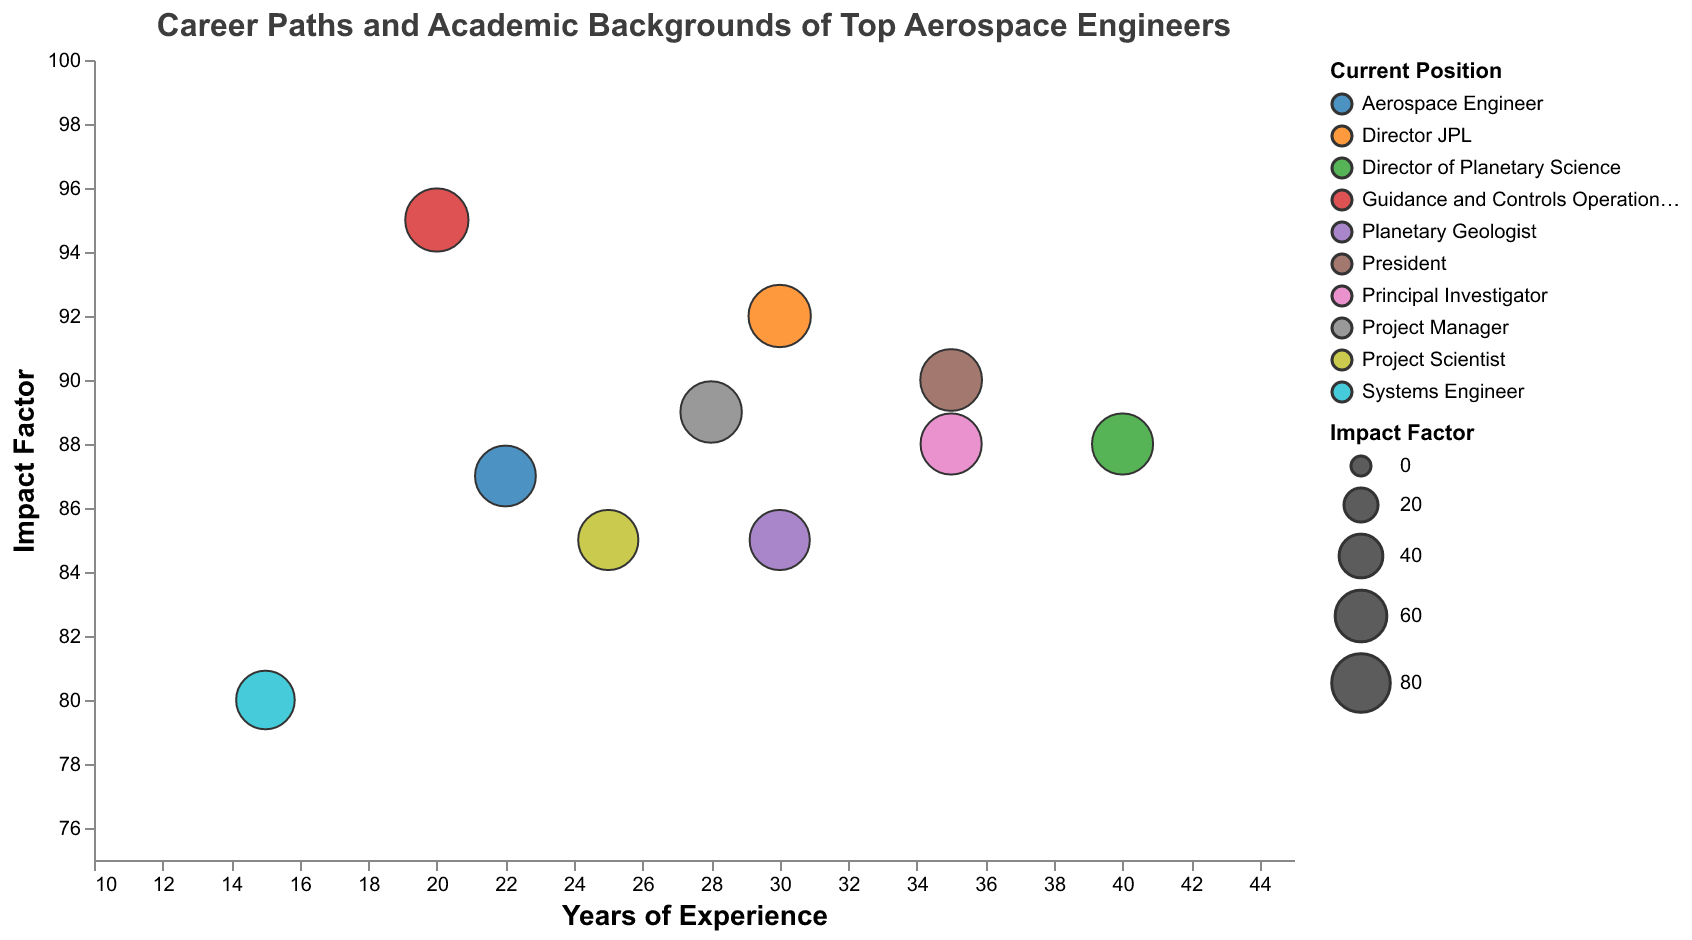How many engineers have an impact factor greater than 90? By examining the y-axis and observing the data points, we can count the number of bubbles whose 'Impact Factor' is above 90.
Answer: 3 Who among the engineers has the highest 'Impact Factor' and what is their current position? The highest 'Impact Factor' can be found by observing the data point at the highest position on the y-axis. Look at the tooltip to identify the engineer and their current position.
Answer: Dr. Swati Mohan, Guidance and Controls Operations Lead Which engineer with over 30 years of experience has the lowest 'Impact Factor'? Filter the data points for those with more than 30 years of experience by looking at the x-axis, and among these, identify the one with the lowest position on the y-axis.
Answer: Dr. Ellen Stofan What is the average 'Impact Factor' of engineers with exactly 30 years of experience? There are three engineers with 30 years of experience. Find their 'Impact Factors' and then calculate the average: (85 + 85 + 92) / 3 = 87.33
Answer: 87.33 Which position has the most number of engineers represented in the chart? Look at the color-coded groups representing different positions, and count the number of data points for each group.
Answer: PhD Which engineer has contributed to the Perseverance rover landing, and what is their 'Impact Factor'? Locate the specific contribution "Perseverance rover landing" by examining the tooltip of the data points, then note the corresponding 'Impact Factor'.
Answer: Dr. Swati Mohan, 95 Among the engineers with experience ranging from 25 to 30 years, who has the highest 'Impact Factor'? Filter out the data points that fall within 25-30 years of experience from the x-axis and identify the highest value on the y-axis within this range.
Answer: Dr. Michael Watkins Is there any visible correlation between 'Years of Experience' and 'Impact Factor'? Examine whether there is any noticeable trend or relationship between the x-axis (Years of Experience) and the y-axis (Impact Factor).
Answer: No clear correlation Which engineer worked on the Mars Science Laboratory and what is their 'Impact Factor’? Scan the tooltips to identify the engineer associated with the Mars Science Laboratory, then note their 'Impact Factor'.
Answer: Dr. Anita Sengupta, 87 